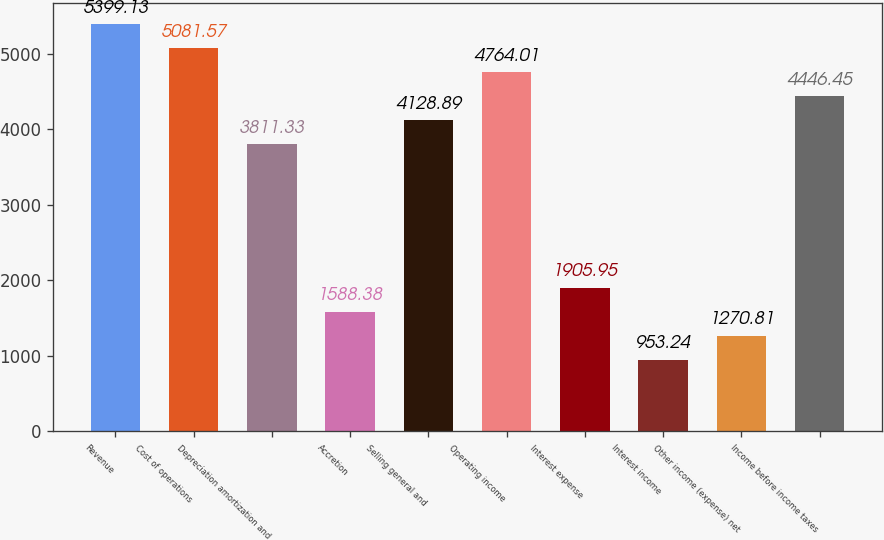Convert chart. <chart><loc_0><loc_0><loc_500><loc_500><bar_chart><fcel>Revenue<fcel>Cost of operations<fcel>Depreciation amortization and<fcel>Accretion<fcel>Selling general and<fcel>Operating income<fcel>Interest expense<fcel>Interest income<fcel>Other income (expense) net<fcel>Income before income taxes<nl><fcel>5399.13<fcel>5081.57<fcel>3811.33<fcel>1588.38<fcel>4128.89<fcel>4764.01<fcel>1905.95<fcel>953.24<fcel>1270.81<fcel>4446.45<nl></chart> 